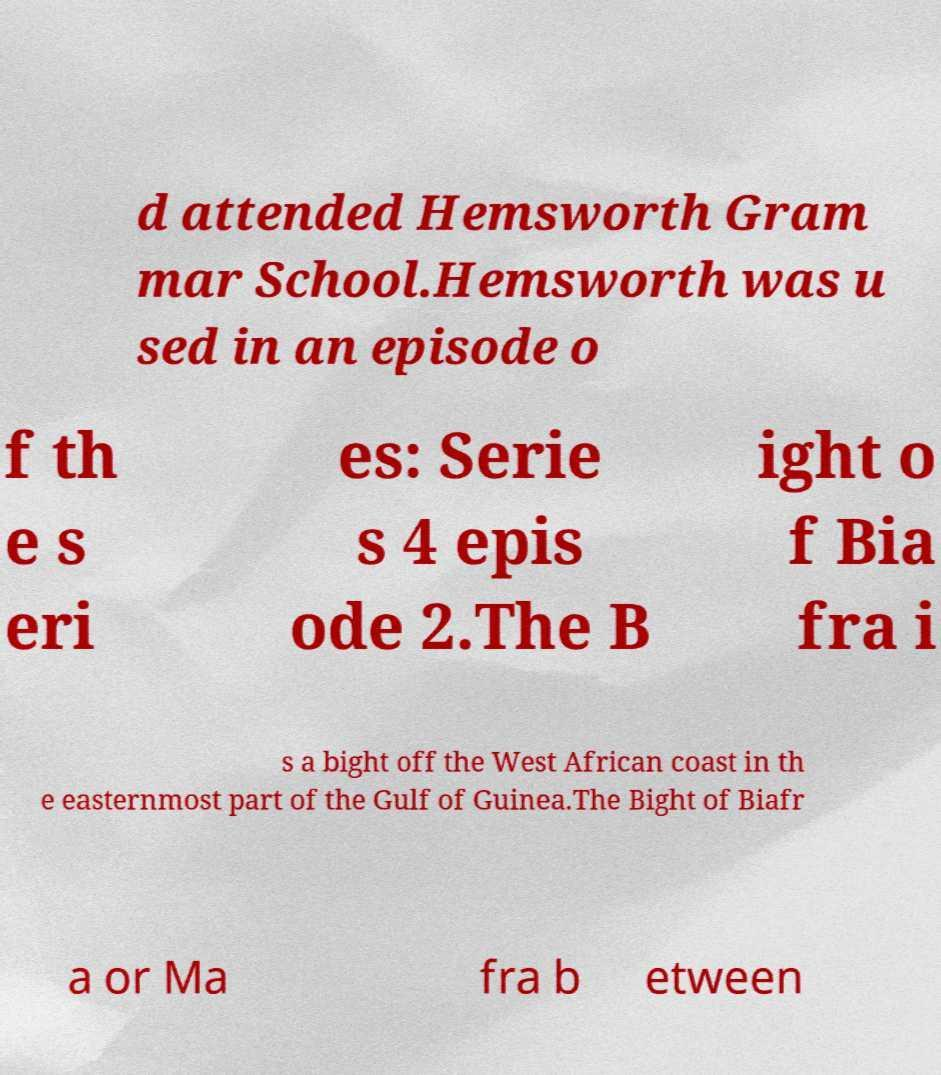There's text embedded in this image that I need extracted. Can you transcribe it verbatim? d attended Hemsworth Gram mar School.Hemsworth was u sed in an episode o f th e s eri es: Serie s 4 epis ode 2.The B ight o f Bia fra i s a bight off the West African coast in th e easternmost part of the Gulf of Guinea.The Bight of Biafr a or Ma fra b etween 